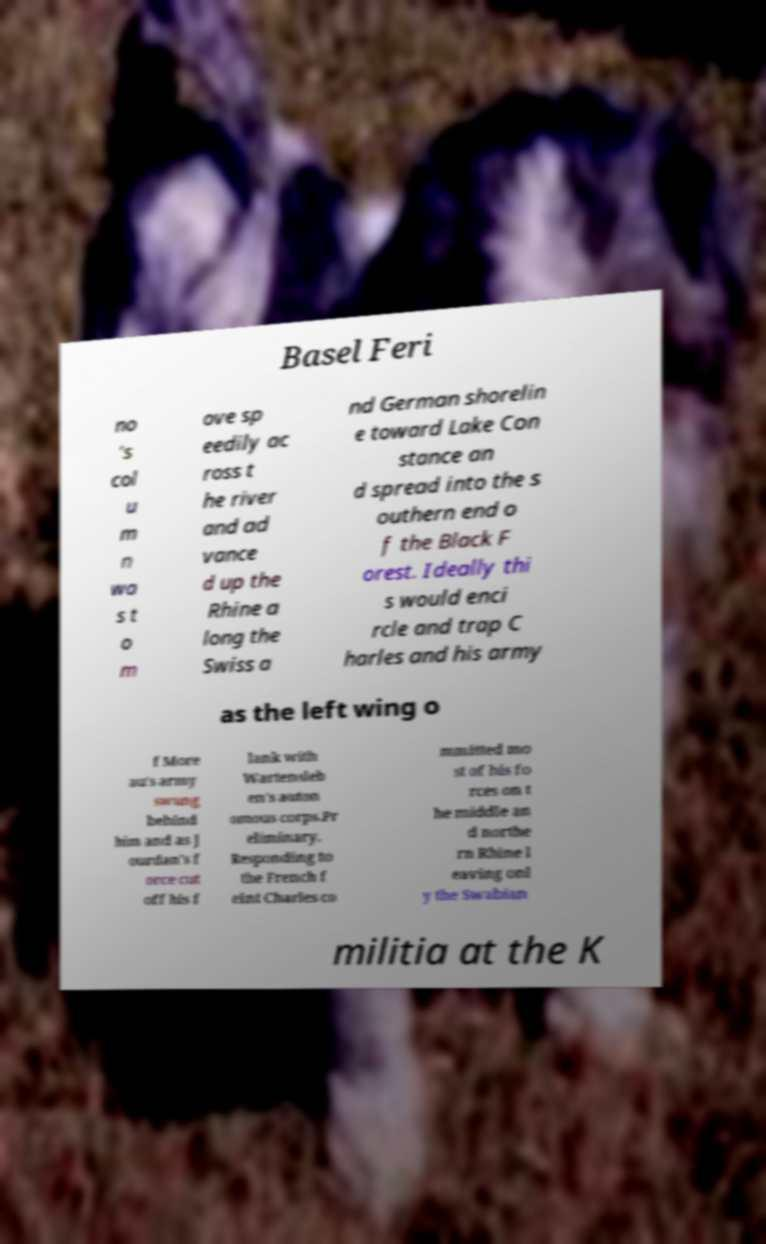Can you accurately transcribe the text from the provided image for me? Basel Feri no ’s col u m n wa s t o m ove sp eedily ac ross t he river and ad vance d up the Rhine a long the Swiss a nd German shorelin e toward Lake Con stance an d spread into the s outhern end o f the Black F orest. Ideally thi s would enci rcle and trap C harles and his army as the left wing o f More au's army swung behind him and as J ourdan's f orce cut off his f lank with Wartensleb en's auton omous corps.Pr eliminary. Responding to the French f eint Charles co mmitted mo st of his fo rces on t he middle an d northe rn Rhine l eaving onl y the Swabian militia at the K 